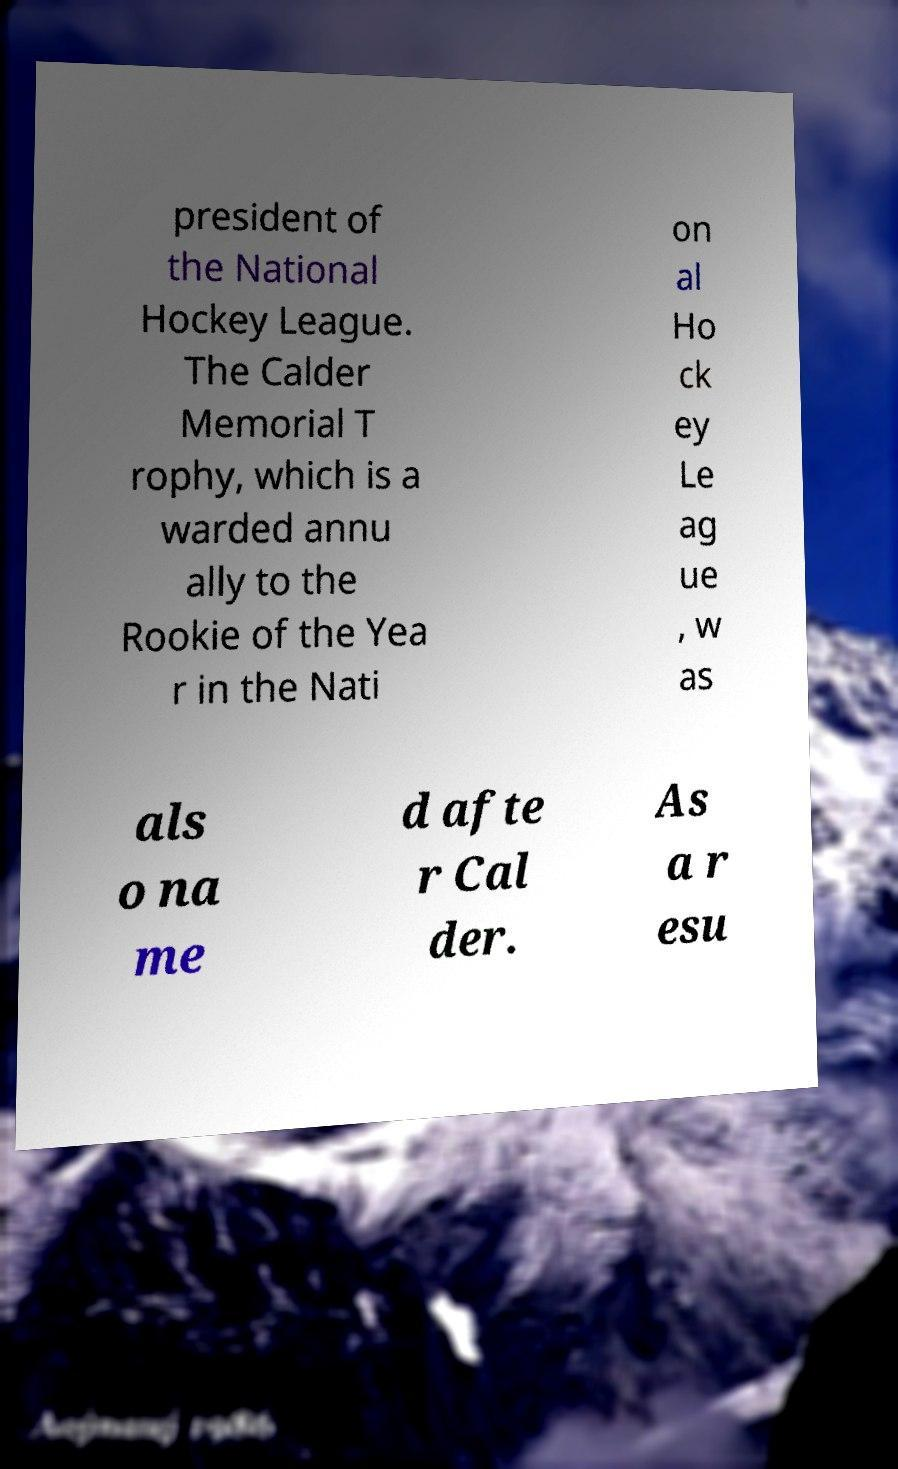What messages or text are displayed in this image? I need them in a readable, typed format. president of the National Hockey League. The Calder Memorial T rophy, which is a warded annu ally to the Rookie of the Yea r in the Nati on al Ho ck ey Le ag ue , w as als o na me d afte r Cal der. As a r esu 